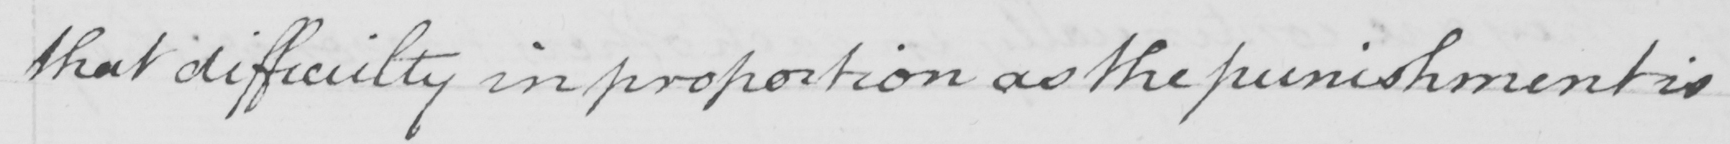What is written in this line of handwriting? that difficulty in proportion as the punishment is 